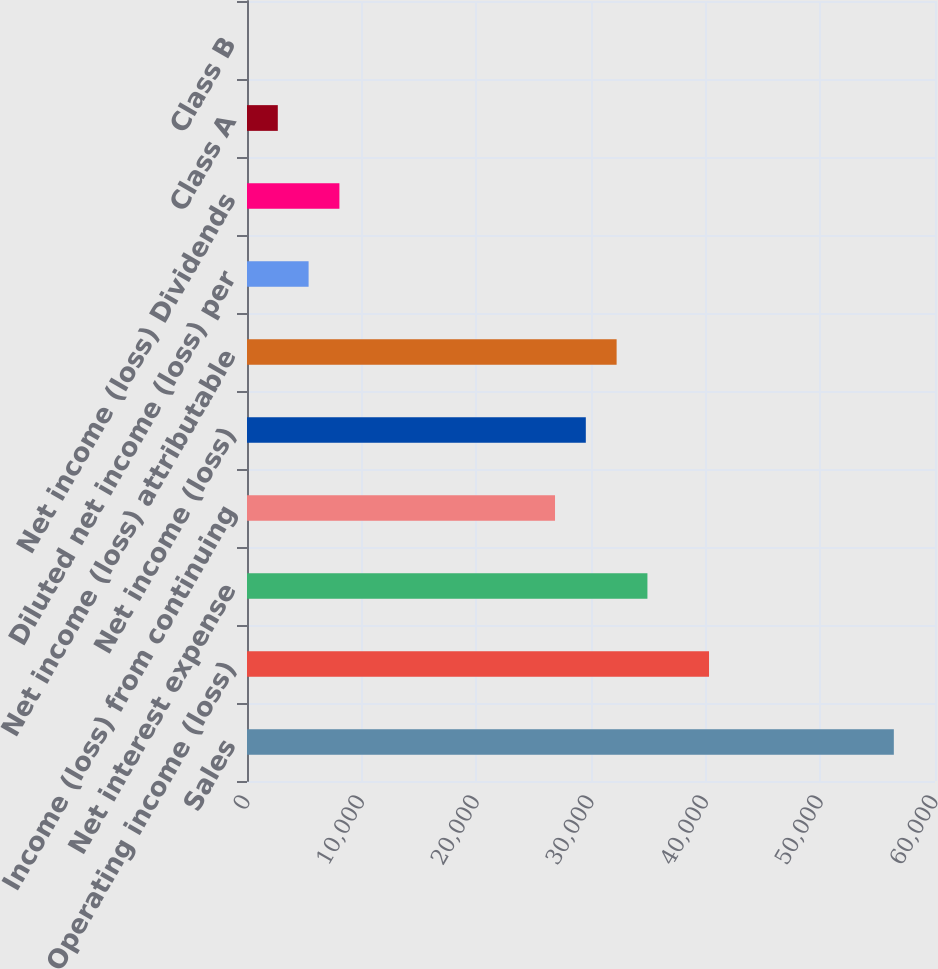Convert chart. <chart><loc_0><loc_0><loc_500><loc_500><bar_chart><fcel>Sales<fcel>Operating income (loss)<fcel>Net interest expense<fcel>Income (loss) from continuing<fcel>Net income (loss)<fcel>Net income (loss) attributable<fcel>Diluted net income (loss) per<fcel>Net income (loss) Dividends<fcel>Class A<fcel>Class B<nl><fcel>56410.1<fcel>40293<fcel>34920.6<fcel>26862<fcel>29548.2<fcel>32234.4<fcel>5372.52<fcel>8058.71<fcel>2686.33<fcel>0.14<nl></chart> 